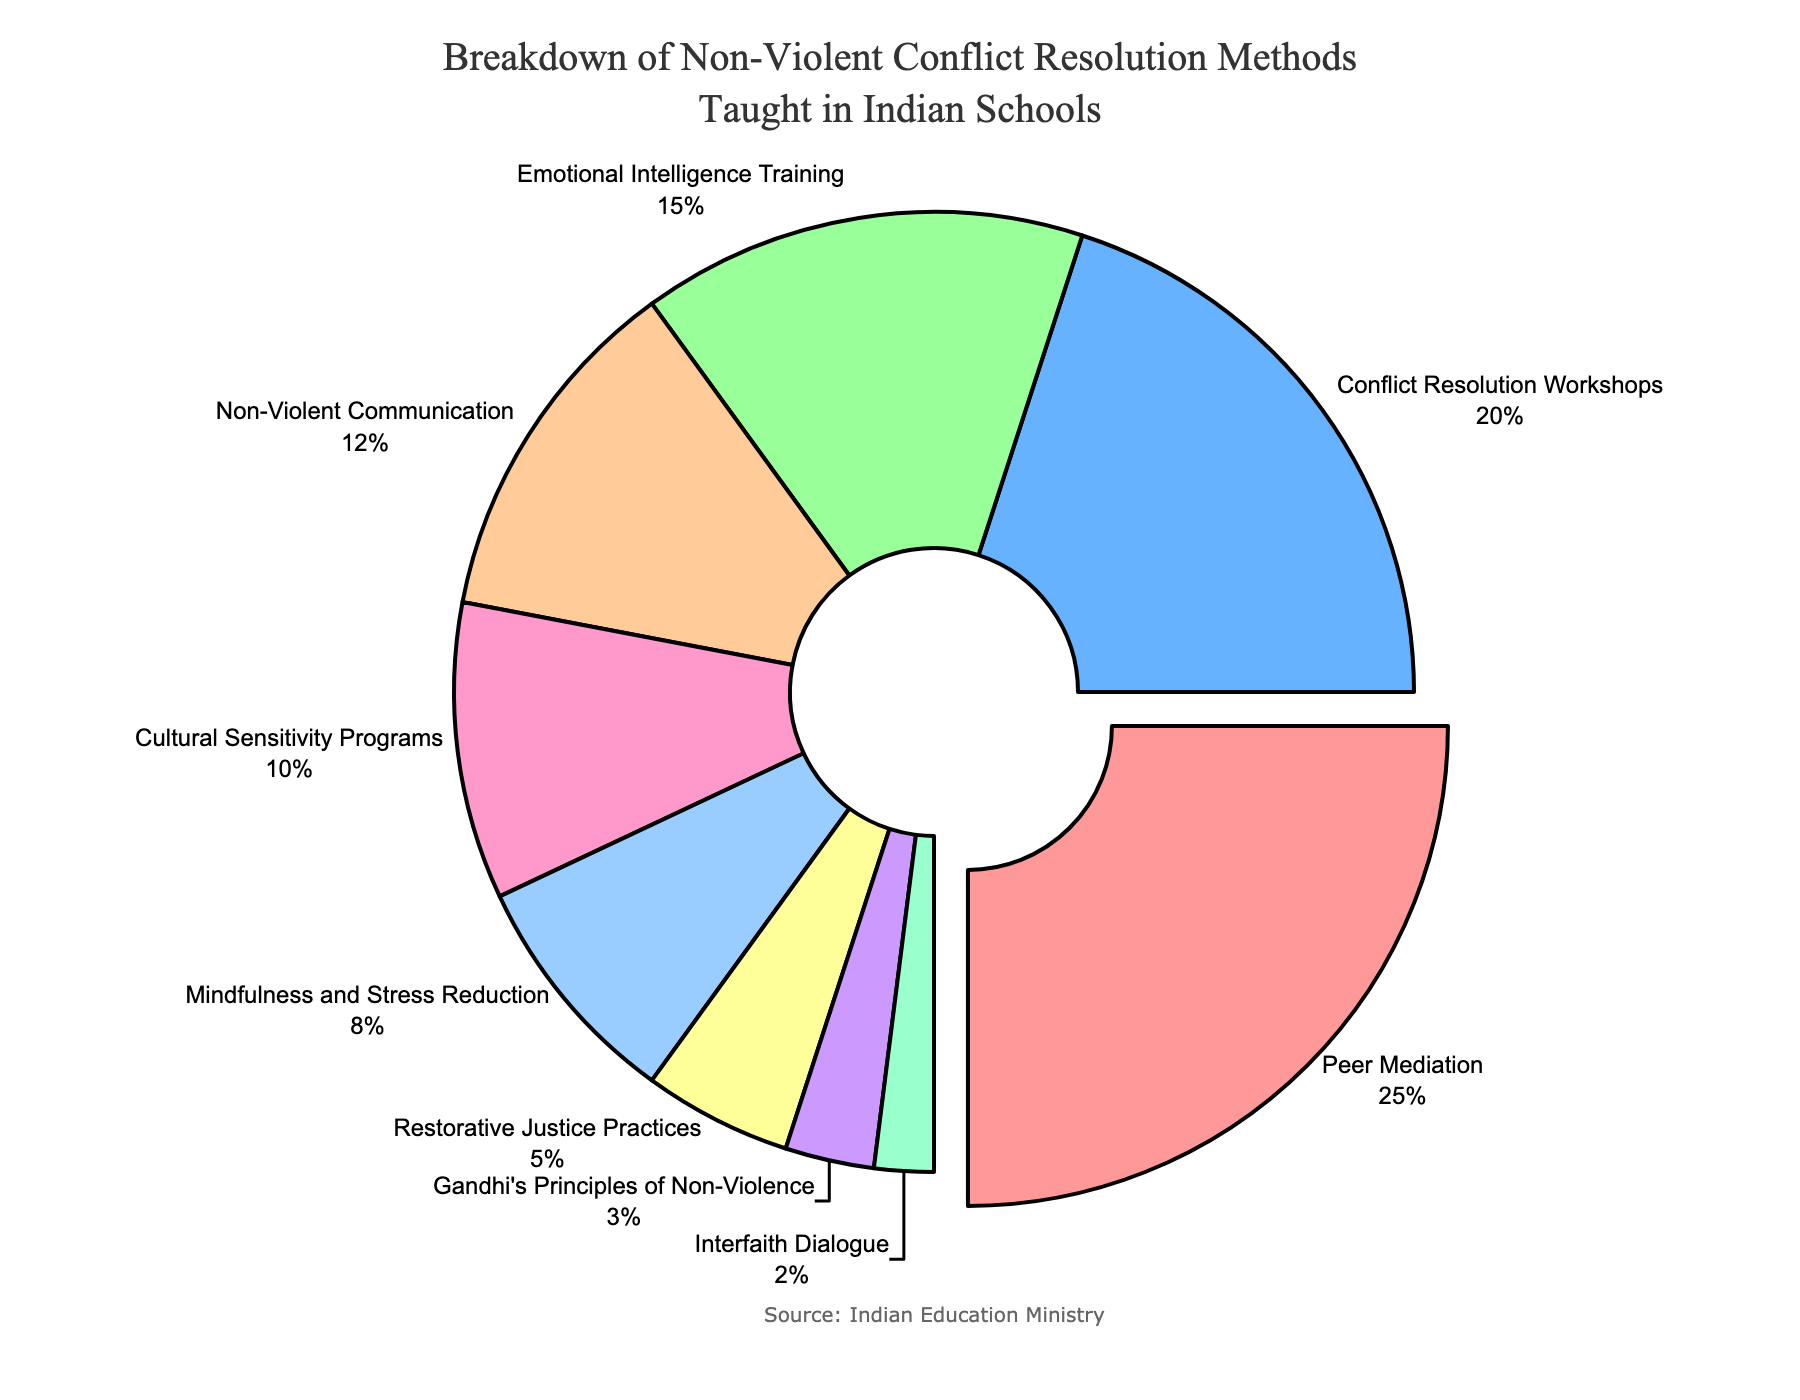what is the second most common non-violent conflict resolution method taught in Indian schools? The pie chart indicates the portions of various resolution methods. The second largest section is labeled "Conflict Resolution Workshops" with a percentage value of 20%.
Answer: Conflict Resolution Workshops Which combination of methods accounts for exactly 30%? By adding up the percentages, we find that "Non-Violent Communication" (12%) and "Cultural Sensitivity Programs" (10%) together result in 22%. Adding "Interfaith Dialogue" (2%) brings the total to 24%. Adding "Restorative Justice Practices" (5%) makes it 29%. Adding "Gandhi's Principles of Non-Violence" (3%) results in exactly 32%. Therefore, by excluding "Cultural Sensitivity Programs" and adding "Mindfulness and Stress Reduction" (8%) to "Non-Violent Communication" (12%), the total becomes exactly 30%.
Answer: Non-Violent Communication, Mindfulness and Stress Reduction Is peer mediation more popular than emotional intelligence training? Peer Mediation accounts for 25%, while Emotional Intelligence Training accounts for 15%. 25% is greater than 15%.
Answer: Yes What is the least emphasized method among those listed? The smallest slice of the pie is labeled "Interfaith Dialogue" with a percentage value of 2%.
Answer: Interfaith Dialogue How much more common is Conflict Resolution Workshops compared to Gandhi's Principles of Non-Violence? Conflict Resolution Workshops account for 20%, while Gandhi's Principles of Non-Violence account for 3%. The difference is 20% - 3% = 17%.
Answer: 17% Which methods combined make up more than half of the pie chart? Adding up the sections: Peer Mediation (25%) + Conflict Resolution Workshops (20%) = 45%. Including Emotional Intelligence Training (15%) makes it 60%, which is more than half.
Answer: Peer Mediation, Conflict Resolution Workshops, Emotional Intelligence Training What percentage is covered by the least three methods combined? Gandhi's Principles of Non-Violence (3%) + Interfaith Dialogue (2%) + Restorative Justice Practices (5%) = 3% + 2% + 5% = 10%.
Answer: 10% How do the percentages for Cultural Sensitivity Programs and Mindfulness and Stress Reduction compare? Cultural Sensitivity Programs account for 10% and Mindfulness and Stress Reduction accounts for 8%. 10% is greater than 8%.
Answer: Cultural Sensitivity Programs > Mindfulness and Stress Reduction 